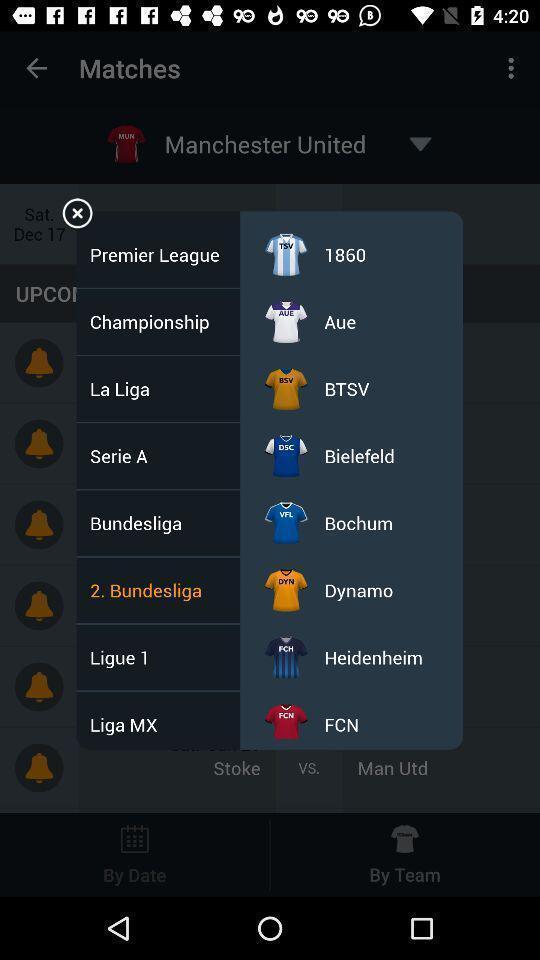Explain what's happening in this screen capture. Pop-up shows list of options in sports app. 